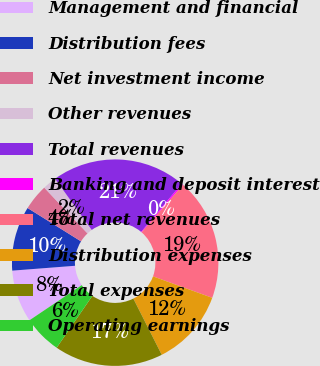<chart> <loc_0><loc_0><loc_500><loc_500><pie_chart><fcel>Management and financial<fcel>Distribution fees<fcel>Net investment income<fcel>Other revenues<fcel>Total revenues<fcel>Banking and deposit interest<fcel>Total net revenues<fcel>Distribution expenses<fcel>Total expenses<fcel>Operating earnings<nl><fcel>8.19%<fcel>10.11%<fcel>4.07%<fcel>2.16%<fcel>21.04%<fcel>0.25%<fcel>19.13%<fcel>12.02%<fcel>17.04%<fcel>5.99%<nl></chart> 